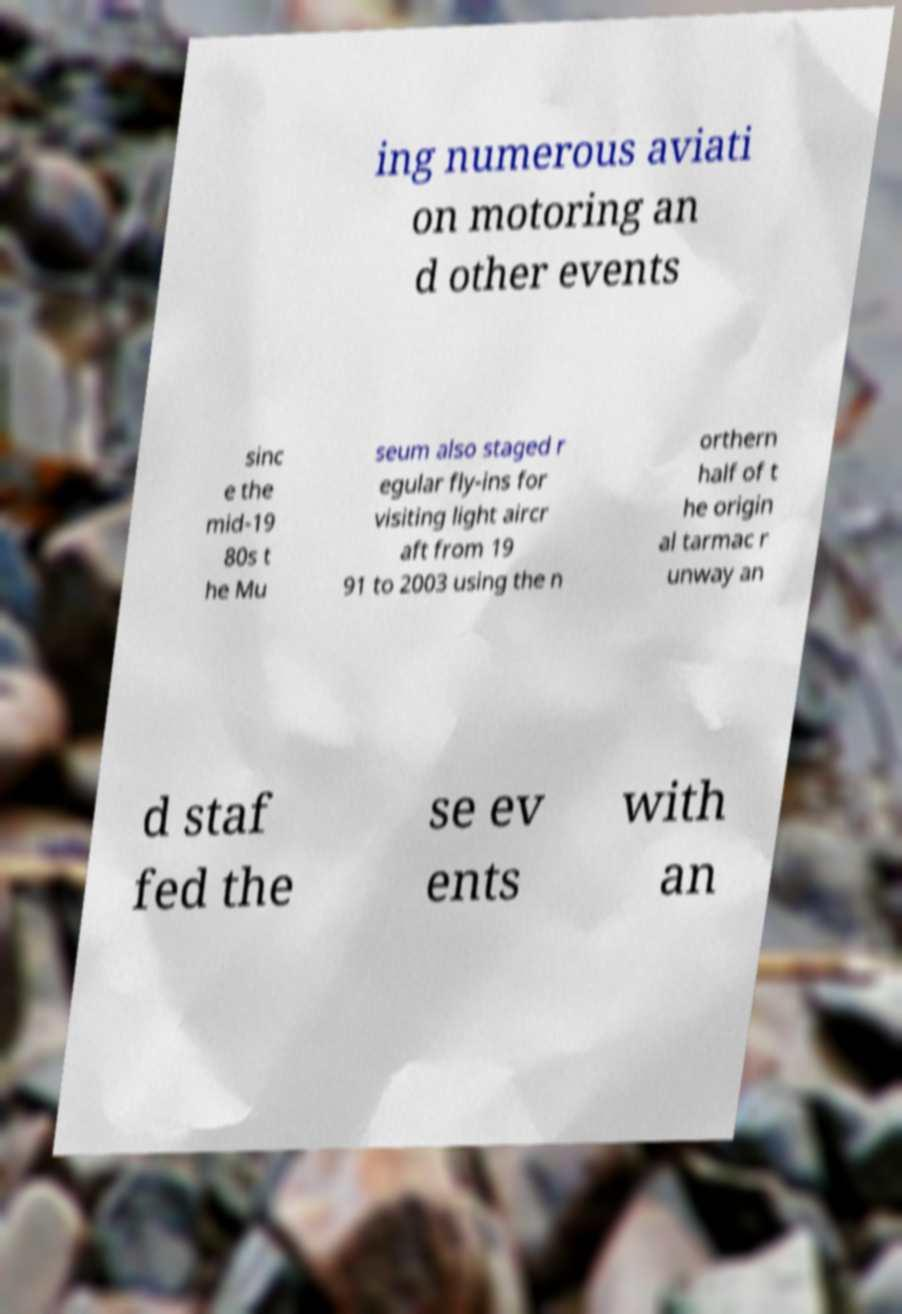What messages or text are displayed in this image? I need them in a readable, typed format. ing numerous aviati on motoring an d other events sinc e the mid-19 80s t he Mu seum also staged r egular fly-ins for visiting light aircr aft from 19 91 to 2003 using the n orthern half of t he origin al tarmac r unway an d staf fed the se ev ents with an 